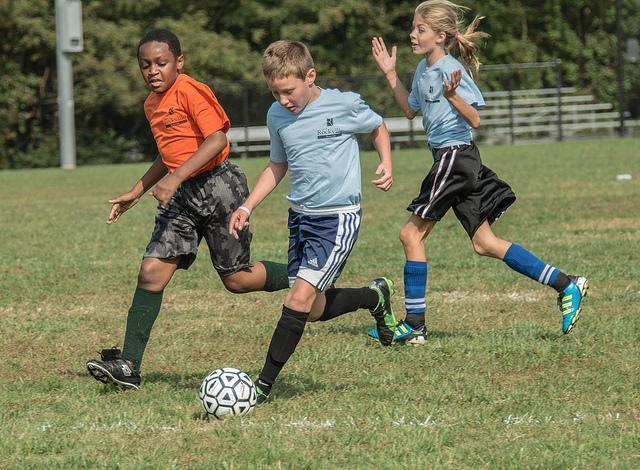How many people are in the picture?
Give a very brief answer. 3. How many boys are playing?
Give a very brief answer. 2. How many people are there?
Give a very brief answer. 3. 